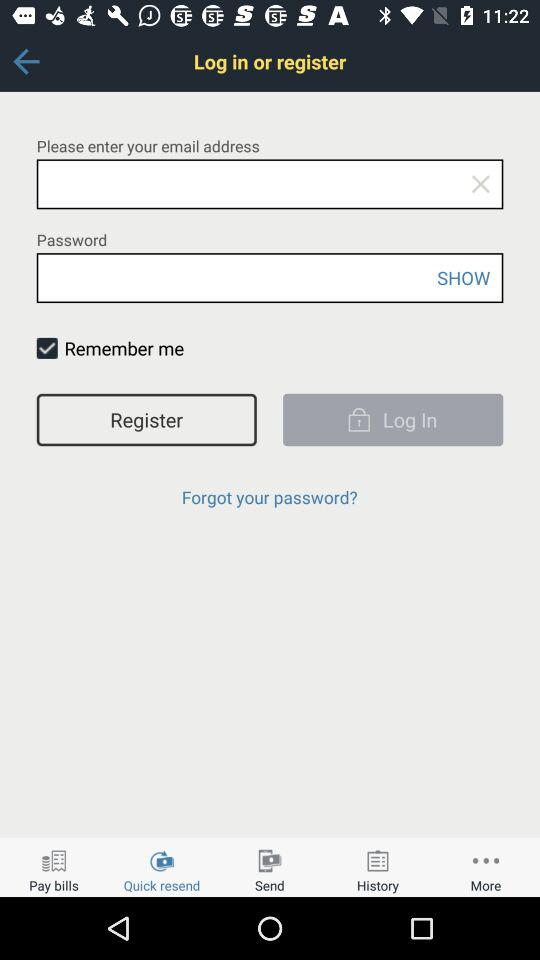What is the status of "Remember me"? The status is "on". 